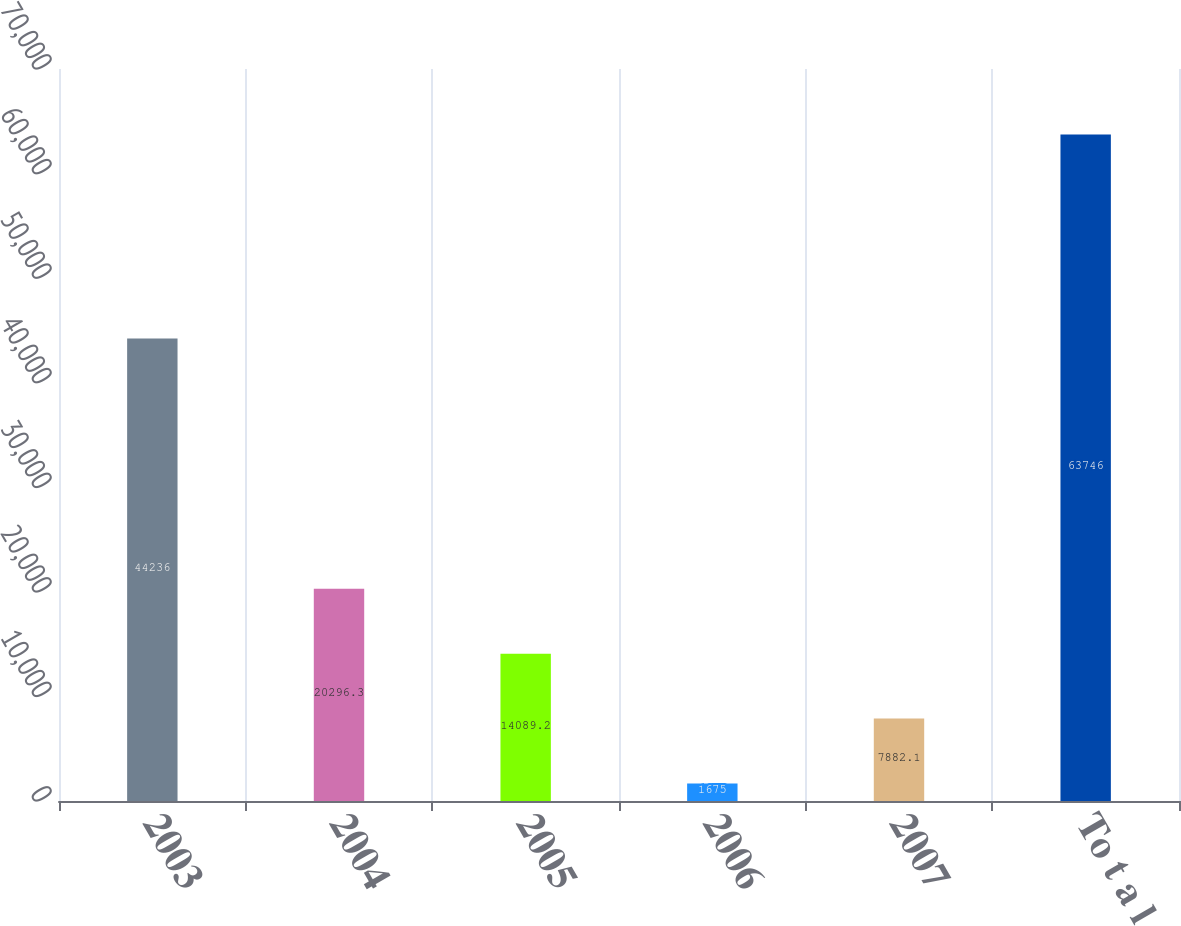Convert chart to OTSL. <chart><loc_0><loc_0><loc_500><loc_500><bar_chart><fcel>2003<fcel>2004<fcel>2005<fcel>2006<fcel>2007<fcel>To t a l<nl><fcel>44236<fcel>20296.3<fcel>14089.2<fcel>1675<fcel>7882.1<fcel>63746<nl></chart> 